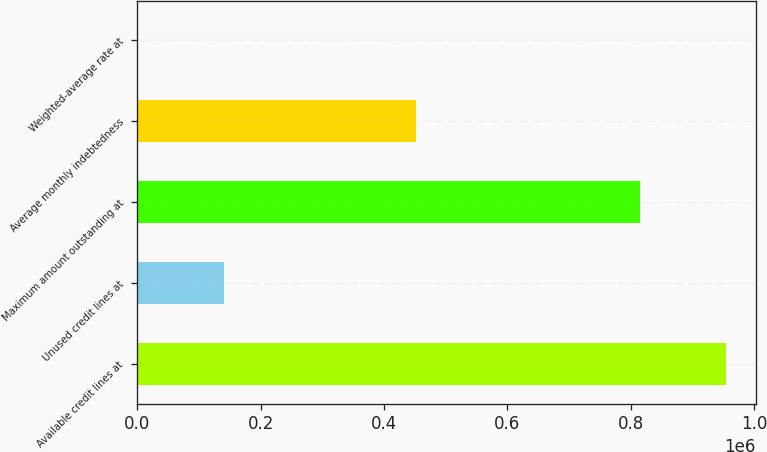Convert chart to OTSL. <chart><loc_0><loc_0><loc_500><loc_500><bar_chart><fcel>Available credit lines at<fcel>Unused credit lines at<fcel>Maximum amount outstanding at<fcel>Average monthly indebtedness<fcel>Weighted-average rate at<nl><fcel>955000<fcel>140000<fcel>815000<fcel>452000<fcel>5.81<nl></chart> 